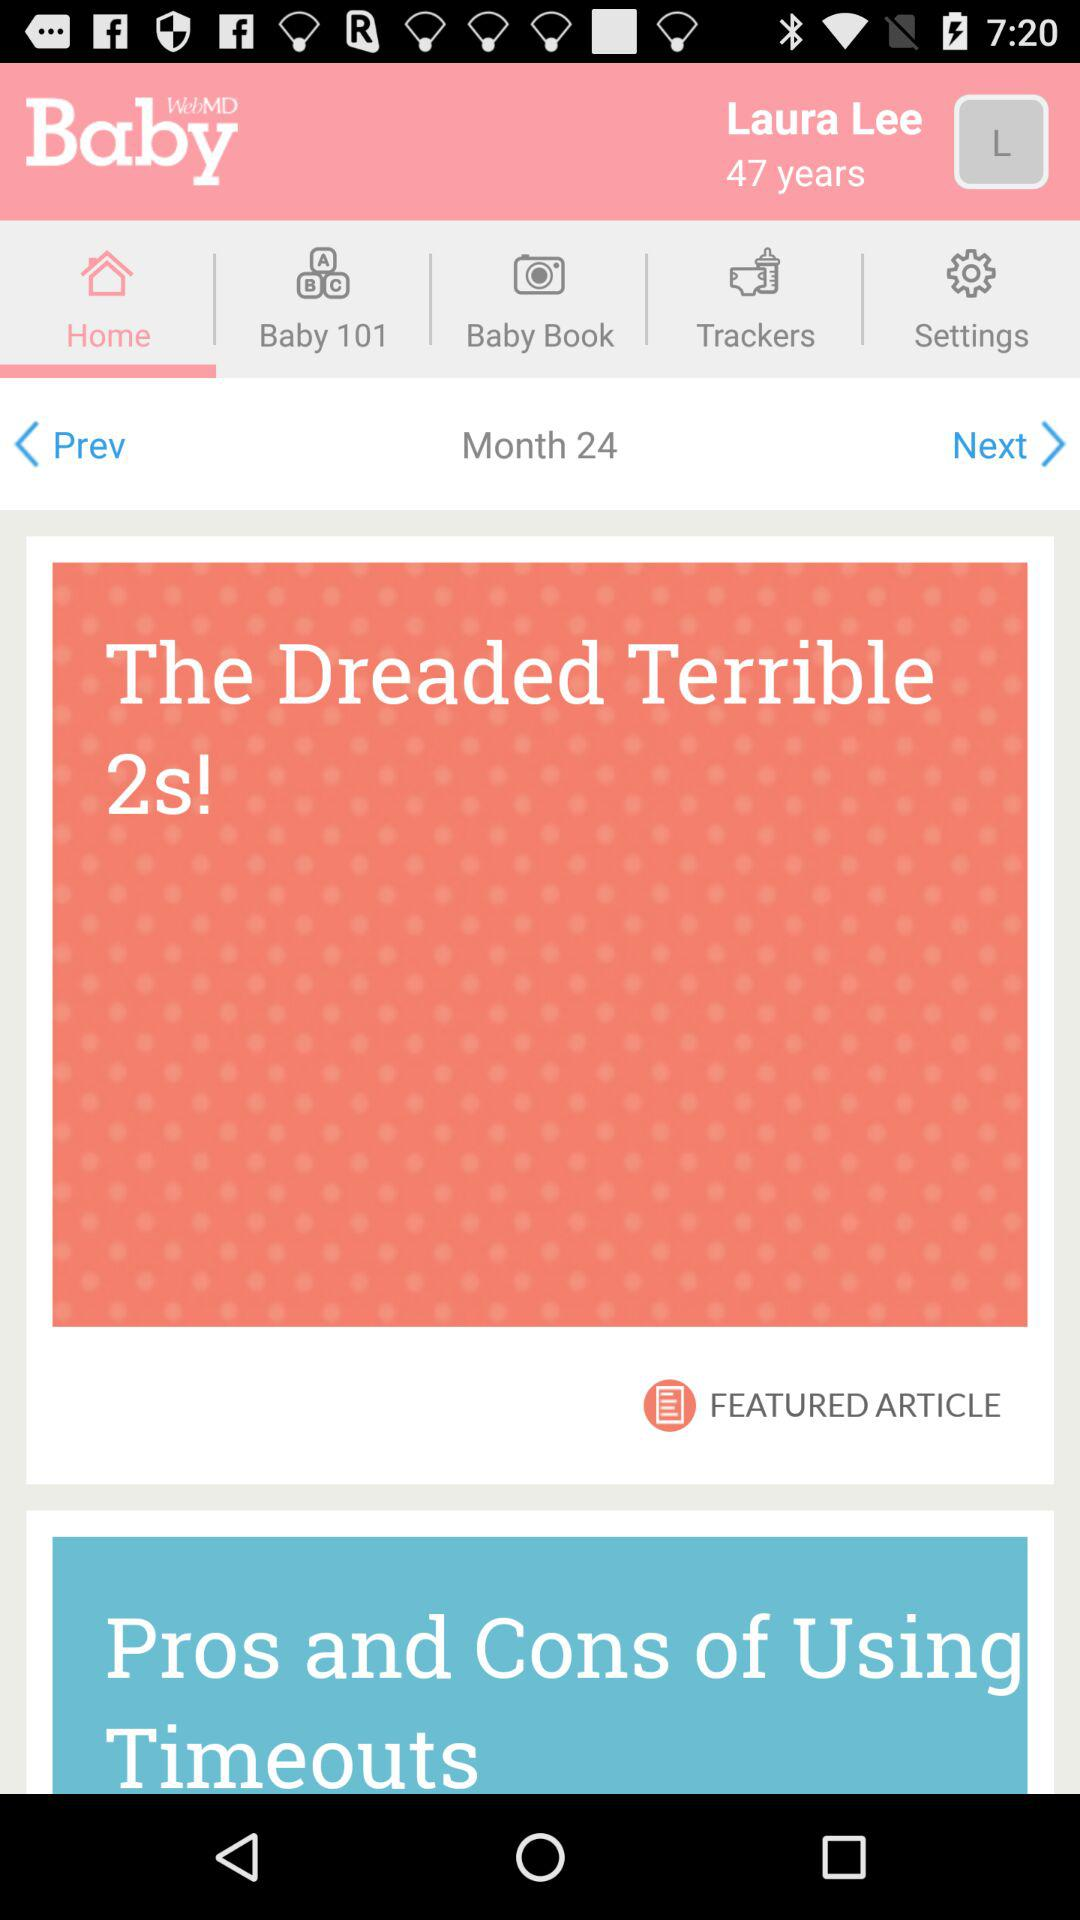Which tab is selected? The selected tab is "Home". 